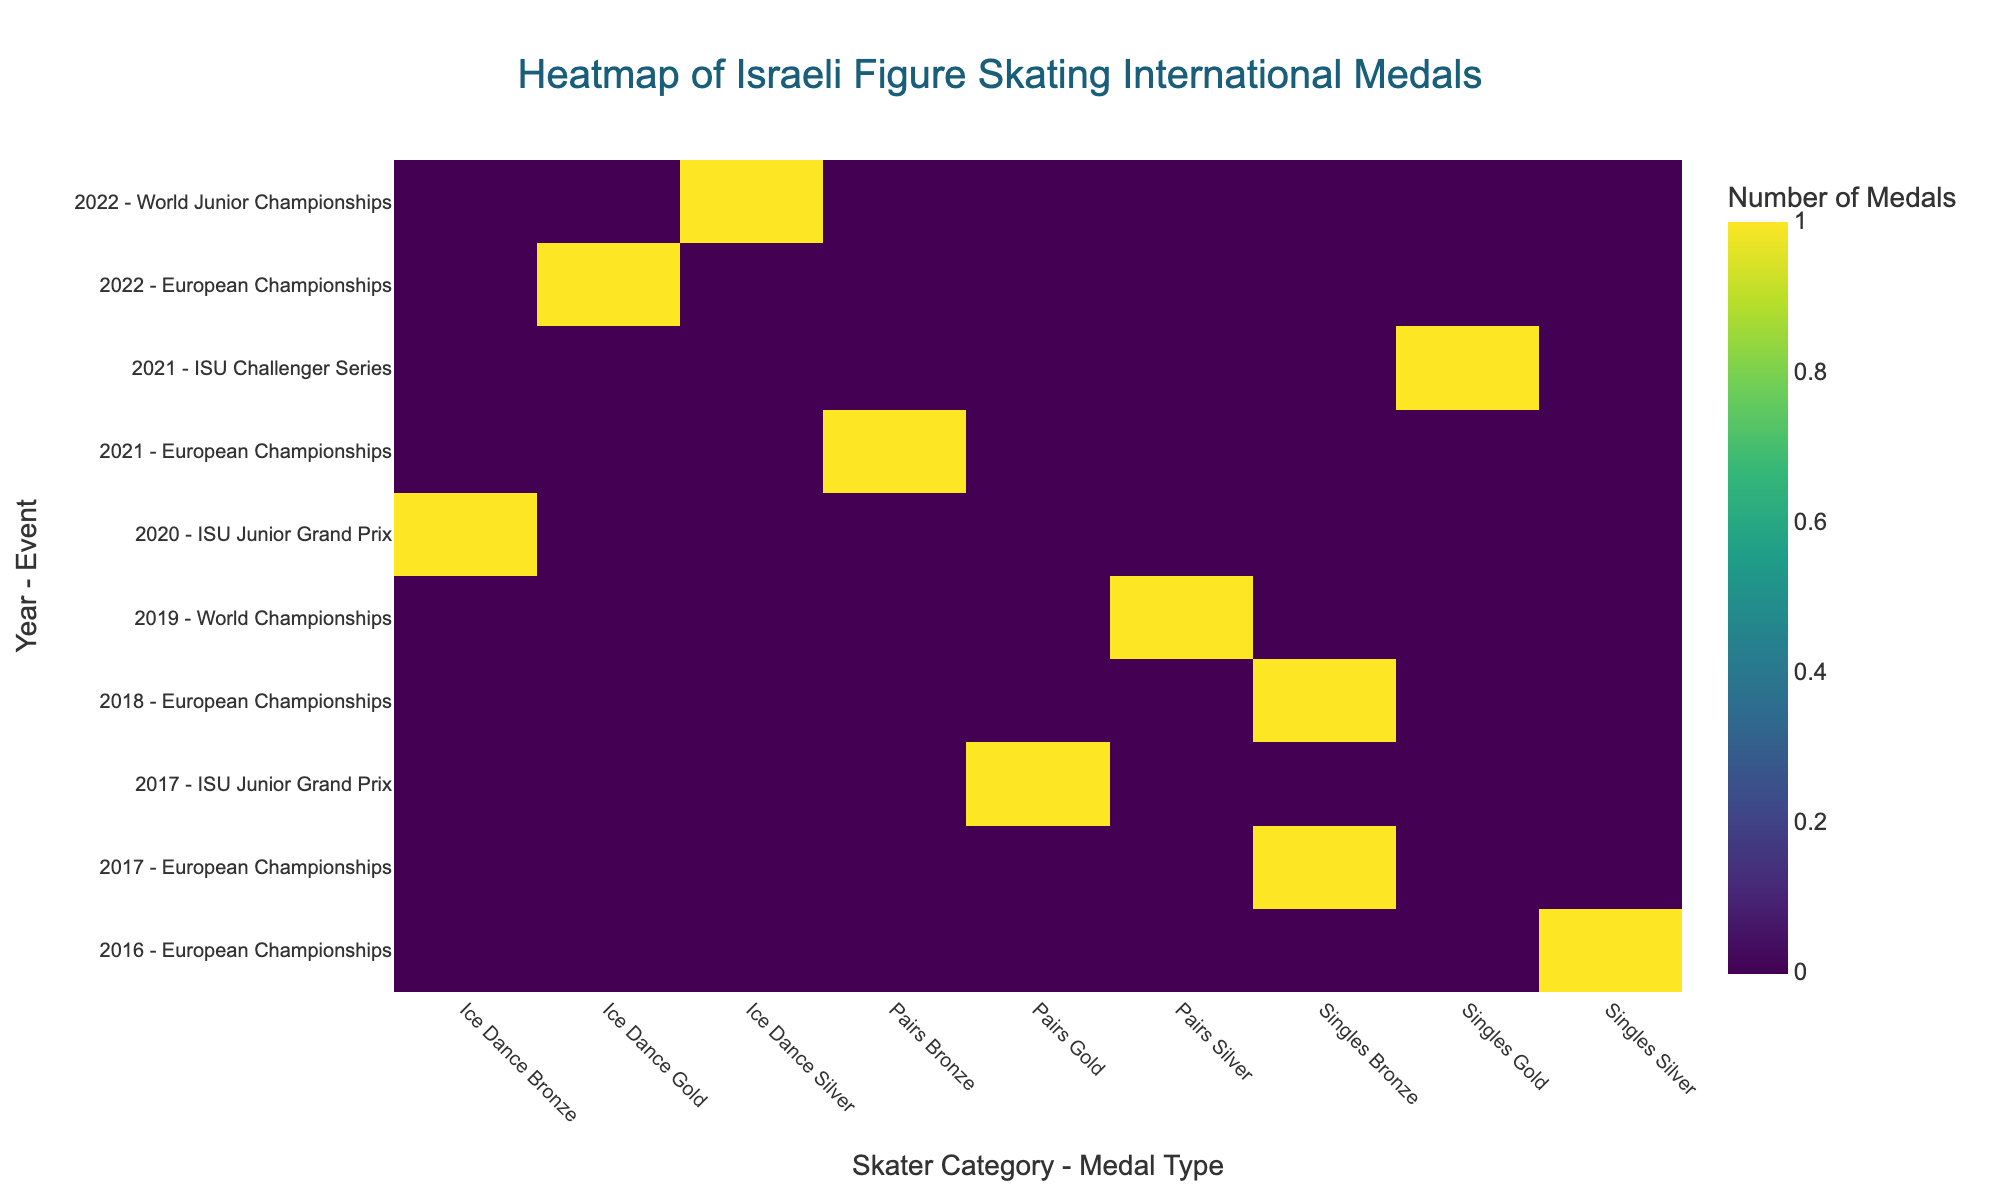What is the title of the heatmap? The title is typically located at the top center of the graph and provides a description of what the figure represents.
Answer: Heatmap of Israeli Figure Skating International Medals Which year-event combination won the highest number of Gold medals in any Skater Category? By looking for the brightest spots under the Gold category columns in the heatmap, we can identify the highest number of Gold medals.
Answer: 2022 - European Championships How many Bronze medals were won across all events and years in the "Singles" category? Sum up the values for Bronze medals in the Singles category by going through each relevant cell in the column for Singles - Bronze.
Answer: 2 Compare the number of Silver medals won in 2019 and 2016. Which year had more, and how many more? Check the values for Silver medals in each year and then calculate the difference between the two values.
Answer: 2019 had more by 1 medal Did Israeli figure skaters win more medals in the Pairs category or the Ice Dance category? Sum the total number of medals (Gold, Silver, and Bronze) for both Pairs and Ice Dance categories and compare the totals.
Answer: Pairs Which year had the most diverse medal types (Gold, Silver, Bronze) across various events? Look for the year that has cells with non-zero values spread across the most different Medal Type columns (Gold, Silver, Bronze).
Answer: 2022 What was the total number of medals won in the European Championships across all years? Sum the values for all medals in the European Championships rows.
Answer: 5 How many gold medals did Israeli skaters win in the ISU Junior Grand Prix event? Look specifically at the cells under the Gold columns for the ISU Junior Grand Prix rows.
Answer: 1 By how many years did Israeli skaters win at least one medal in any category? Count the number of distinct year labels on the y-axis that have non-zero medal counts in any column.
Answer: 7 In which Skater Category - Medal Type combination did Israeli skaters never achieve a medal? Look for columns with all zero values compared to the others, indicating no medals in that combination.
Answer: Singles - Silver 